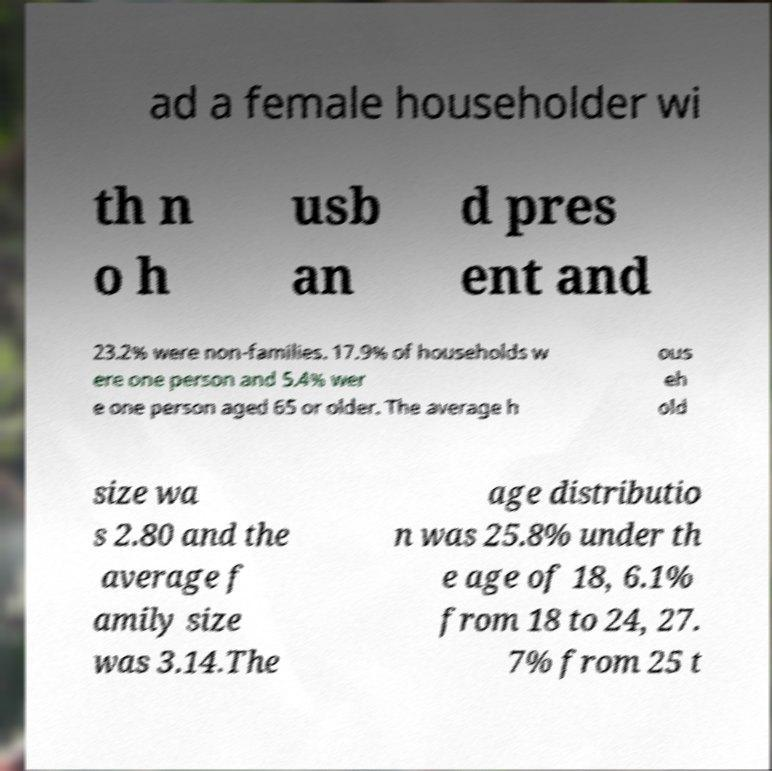For documentation purposes, I need the text within this image transcribed. Could you provide that? ad a female householder wi th n o h usb an d pres ent and 23.2% were non-families. 17.9% of households w ere one person and 5.4% wer e one person aged 65 or older. The average h ous eh old size wa s 2.80 and the average f amily size was 3.14.The age distributio n was 25.8% under th e age of 18, 6.1% from 18 to 24, 27. 7% from 25 t 